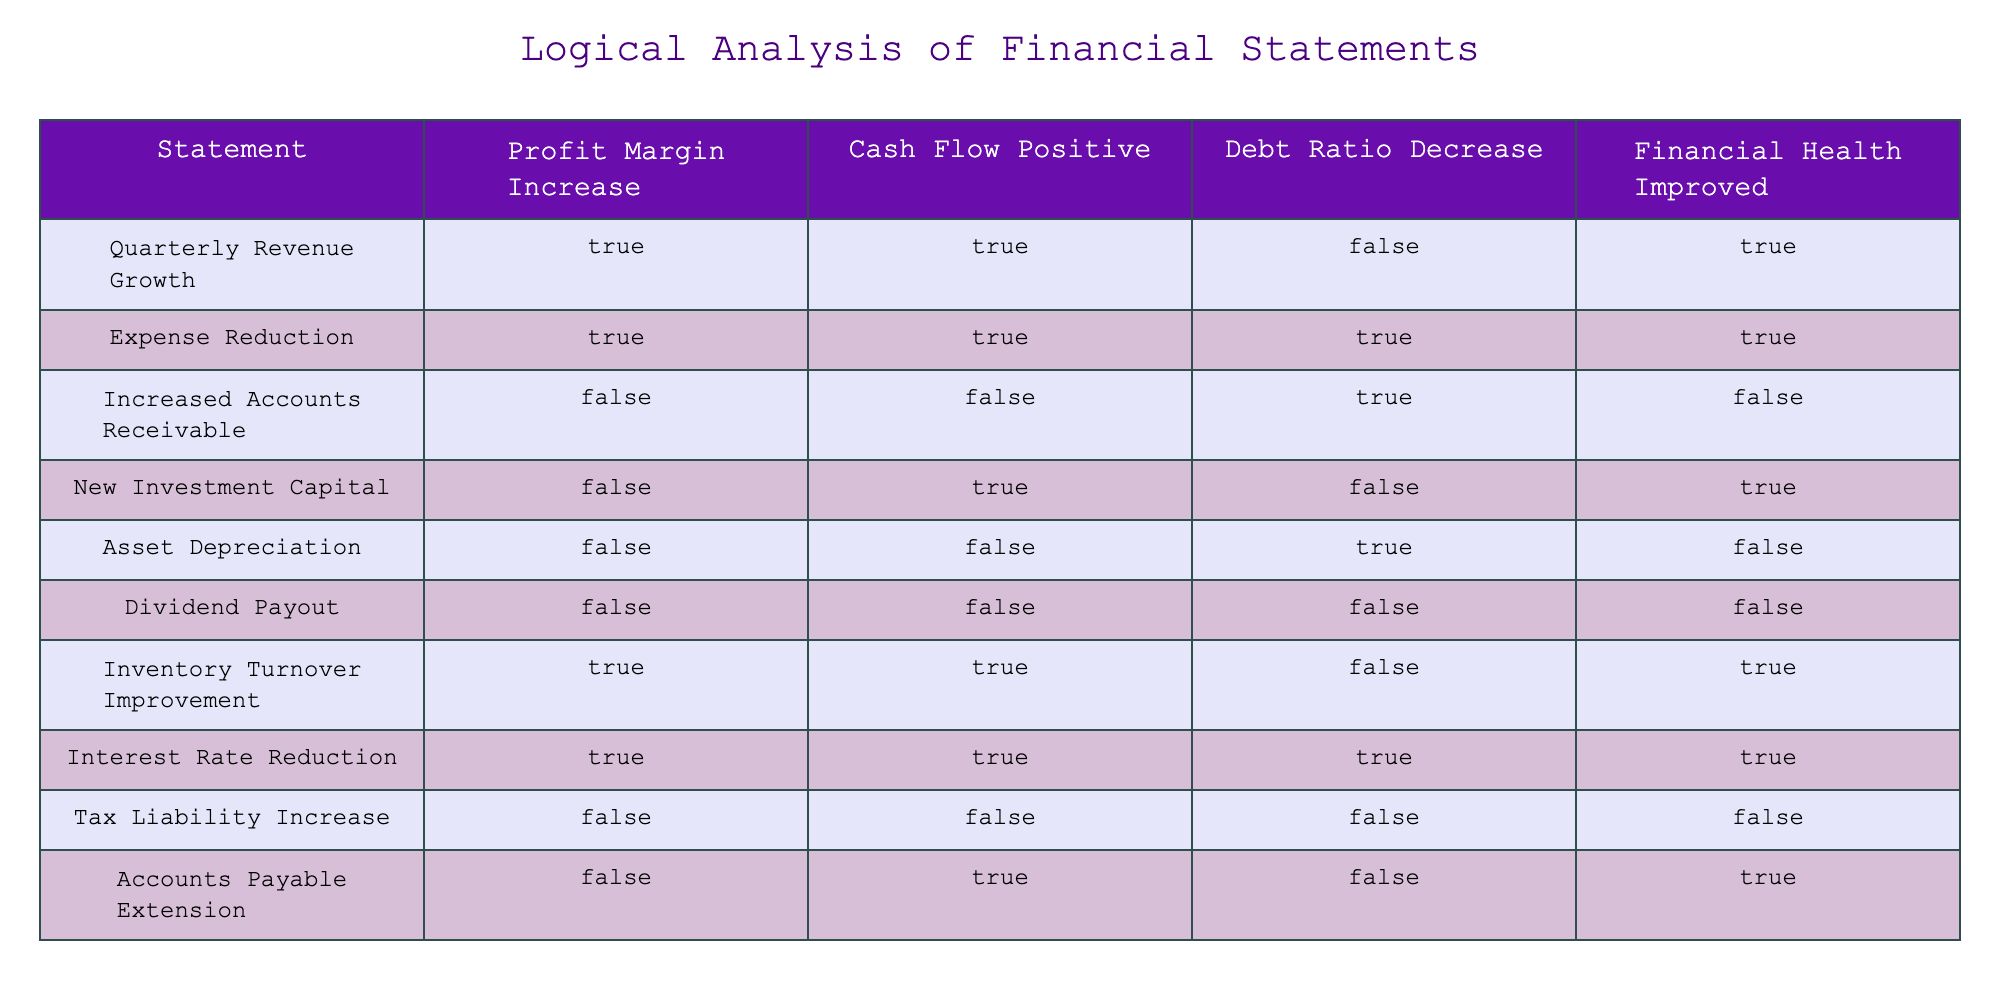What is the profit margin increase for the "Expense Reduction" statement? The table shows that the "Expense Reduction" statement has a "Profit Margin Increase" marked as TRUE. This information can be retrieved directly from the corresponding cell in the table under the chosen statement.
Answer: TRUE Which statement indicates that both cash flow is positive and debt ratio has decreased? By examining the rows of the table, only the "Expense Reduction" and "Interest Rate Reduction" statements show TRUE for both cash flow positive and debt ratio decrease. These two statements meet the criteria specified in the question.
Answer: Expense Reduction, Interest Rate Reduction How many statements show a TRUE value for both profit margin increase and financial health improvement? The table has the following statements with TRUE in both columns: "Quarterly Revenue Growth," "Expense Reduction," "Inventory Turnover Improvement," and "Interest Rate Reduction." Thus, we count a total of four statements that meet this criterion.
Answer: 4 Is it true that a decrease in the debt ratio corresponds always to an improved financial health? The table reveals that the statements "Increased Accounts Receivable" and "Asset Depreciation" both have a TRUE for debt ratio decrease but a FALSE for financial health improvement. Therefore, it is not true that decreasing debt ratio always leads to improved financial health, proving the statement false.
Answer: FALSE What is the total number of statements with a positive cash flow? By tallying the number of statements categorized with cash flow positive (TRUE), we find "Quarterly Revenue Growth," "Expense Reduction," "New Investment Capital," "Inventory Turnover Improvement," and "Accounts Payable Extension." In total, there are five statements indicating positive cash flow.
Answer: 5 Are there any statements that have both cash flow positive and debt ratio decrease? Upon reviewing the table, the statements "Expense Reduction" and "Interest Rate Reduction" both indicate TRUE for cash flow positive and, separately, also indicate TRUE for debt ratio decrease. Therefore, there are statements that satisfy both conditions.
Answer: Yes Which statement has the highest number of TRUE outcomes among the categories presented? Analyzing each row, the "Expense Reduction" statement has TRUE for all categories: profit margin increase, cash flow positive, and debt ratio decrease. This is a total of three TRUE outcomes, which is the highest, compared with other statements that have fewer TRUE values.
Answer: Expense Reduction 